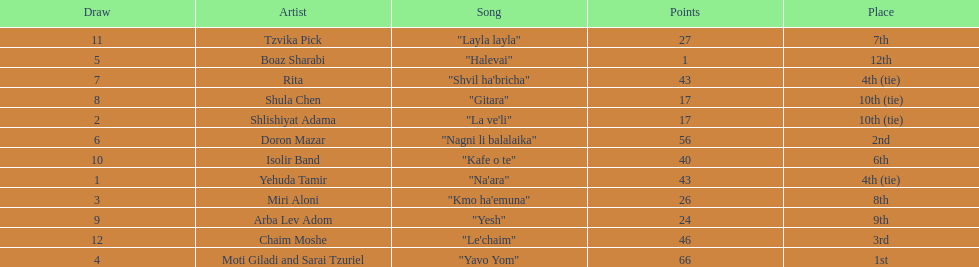What artist received the least amount of points in the competition? Boaz Sharabi. 